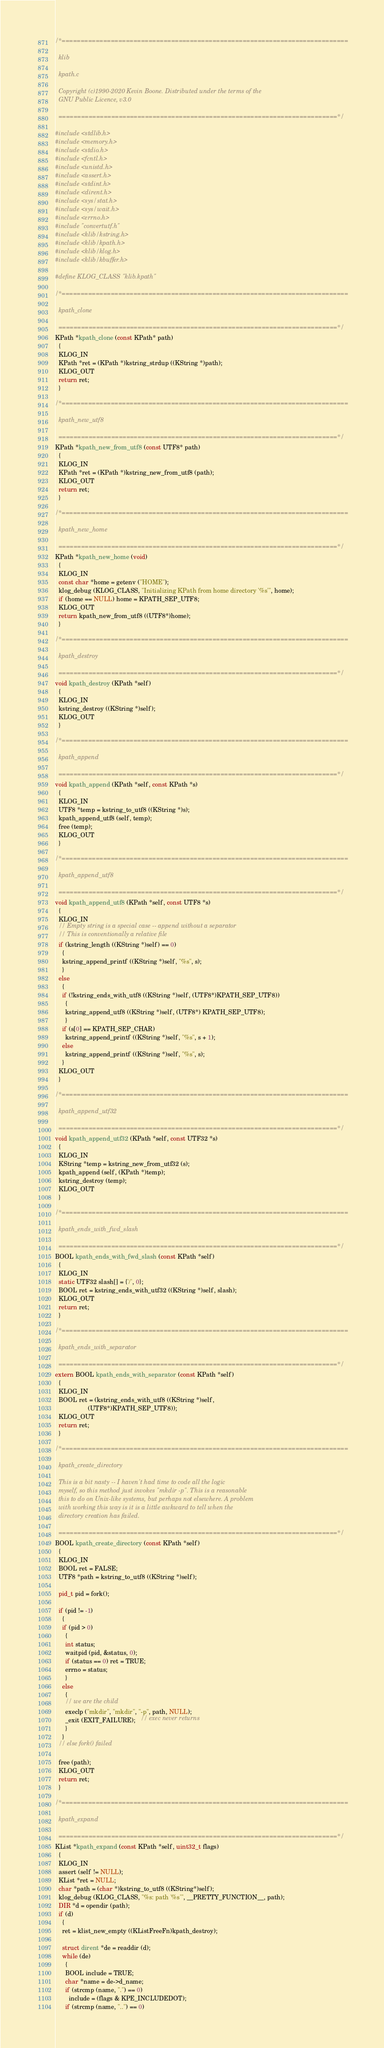Convert code to text. <code><loc_0><loc_0><loc_500><loc_500><_C_>/*============================================================================
  
  klib
  
  kpath.c

  Copyright (c)1990-2020 Kevin Boone. Distributed under the terms of the
  GNU Public Licence, v3.0

  ==========================================================================*/

#include <stdlib.h>
#include <memory.h>
#include <stdio.h>
#include <fcntl.h>
#include <unistd.h>
#include <assert.h>
#include <stdint.h>
#include <dirent.h>
#include <sys/stat.h>
#include <sys/wait.h>
#include <errno.h>
#include "convertutf.h" 
#include <klib/kstring.h>
#include <klib/kpath.h>
#include <klib/klog.h>
#include <klib/kbuffer.h>

#define KLOG_CLASS "klib.kpath"

/*============================================================================
  
  kpath_clone

  ==========================================================================*/
KPath *kpath_clone (const KPath* path) 
  {
  KLOG_IN
  KPath *ret = (KPath *)kstring_strdup ((KString *)path);
  KLOG_OUT
  return ret;
  }

/*============================================================================
  
  kpath_new_utf8 

  ==========================================================================*/
KPath *kpath_new_from_utf8 (const UTF8* path) 
  {
  KLOG_IN
  KPath *ret = (KPath *)kstring_new_from_utf8 (path);
  KLOG_OUT
  return ret;
  }

/*============================================================================
  
  kpath_new_home

  ==========================================================================*/
KPath *kpath_new_home (void)
  {
  KLOG_IN
  const char *home = getenv ("HOME");
  klog_debug (KLOG_CLASS, "Initializing KPath from home directory '%s'", home);
  if (home == NULL) home = KPATH_SEP_UTF8; 
  KLOG_OUT
  return kpath_new_from_utf8 ((UTF8*)home);
  }

/*============================================================================
  
  kpath_destroy

  ==========================================================================*/
void kpath_destroy (KPath *self)
  {
  KLOG_IN
  kstring_destroy ((KString *)self);
  KLOG_OUT
  }

/*============================================================================
  
  kpath_append

  ==========================================================================*/
void kpath_append (KPath *self, const KPath *s)
  {
  KLOG_IN
  UTF8 *temp = kstring_to_utf8 ((KString *)s);
  kpath_append_utf8 (self, temp);
  free (temp);
  KLOG_OUT
  }

/*============================================================================
  
  kpath_append_utf8

  ==========================================================================*/
void kpath_append_utf8 (KPath *self, const UTF8 *s)
  {
  KLOG_IN
  // Empty string is a special case -- append without a separator
  // This is conventionally a relative file
  if (kstring_length ((KString *)self) == 0)
    {
    kstring_append_printf ((KString *)self, "%s", s);
    }
  else
    {
    if (!kstring_ends_with_utf8 ((KString *)self, (UTF8*)KPATH_SEP_UTF8))
      {
      kstring_append_utf8 ((KString *)self, (UTF8*) KPATH_SEP_UTF8);
      }
    if (s[0] == KPATH_SEP_CHAR)
      kstring_append_printf ((KString *)self, "%s", s + 1);
    else
      kstring_append_printf ((KString *)self, "%s", s);
    }
  KLOG_OUT
  }

/*============================================================================
  
  kpath_append_utf32

  ==========================================================================*/
void kpath_append_utf32 (KPath *self, const UTF32 *s)
  {
  KLOG_IN
  KString *temp = kstring_new_from_utf32 (s);
  kpath_append (self, (KPath *)temp);
  kstring_destroy (temp);
  KLOG_OUT
  }

/*============================================================================
  
  kpath_ends_with_fwd_slash

  ==========================================================================*/
BOOL kpath_ends_with_fwd_slash (const KPath *self)
  {
  KLOG_IN
  static UTF32 slash[] = {'/', 0};
  BOOL ret = kstring_ends_with_utf32 ((KString *)self, slash);
  KLOG_OUT
  return ret;
  }

/*============================================================================
  
  kpath_ends_with_separator

  ==========================================================================*/
extern BOOL kpath_ends_with_separator (const KPath *self)
  {
  KLOG_IN
  BOOL ret = (kstring_ends_with_utf8 ((KString *)self, 
                   (UTF8*)KPATH_SEP_UTF8));
  KLOG_OUT
  return ret;
  }

/*============================================================================
  
  kpath_create_directory

  This is a bit nasty -- I haven't had time to code all the logic
  myself, so this method just invokes "mkdir -p". This is a reasonable
  this to do on Unix-like systems, but perhaps not elsewhere. A problem
  with working this way is it is a little awkward to tell when the
  directory creation has failed.

  ==========================================================================*/
BOOL kpath_create_directory (const KPath *self)
  {
  KLOG_IN
  BOOL ret = FALSE; 
  UTF8 *path = kstring_to_utf8 ((KString *)self);

  pid_t pid = fork();

  if (pid != -1)
    {
    if (pid > 0)
      {
      int status;
      waitpid (pid, &status, 0);
      if (status == 0) ret = TRUE;
      errno = status;
      }
    else
      {
      // we are the child
      execlp ("mkdir", "mkdir", "-p", path, NULL);
      _exit (EXIT_FAILURE);   // exec never returns
      }
    }
  // else fork() failed

  free (path);
  KLOG_OUT
  return ret;
  }

/*============================================================================
  
  kpath_expand

  ==========================================================================*/
KList *kpath_expand (const KPath *self, uint32_t flags)
  {
  KLOG_IN
  assert (self != NULL);
  KList *ret = NULL;
  char *path = (char *)kstring_to_utf8 ((KString*)self);
  klog_debug (KLOG_CLASS, "%s: path '%s'", __PRETTY_FUNCTION__, path); 
  DIR *d = opendir (path);
  if (d)
    {
    ret = klist_new_empty ((KListFreeFn)kpath_destroy);

    struct dirent *de = readdir (d);
    while (de)
      {
      BOOL include = TRUE;
      char *name = de->d_name;
      if (strcmp (name, ".") == 0)
        include = (flags & KPE_INCLUDEDOT);
      if (strcmp (name, "..") == 0)</code> 